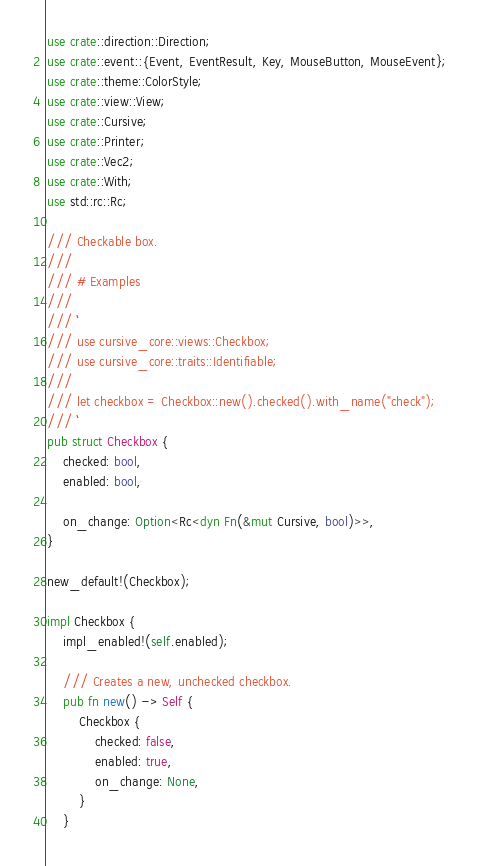Convert code to text. <code><loc_0><loc_0><loc_500><loc_500><_Rust_>use crate::direction::Direction;
use crate::event::{Event, EventResult, Key, MouseButton, MouseEvent};
use crate::theme::ColorStyle;
use crate::view::View;
use crate::Cursive;
use crate::Printer;
use crate::Vec2;
use crate::With;
use std::rc::Rc;

/// Checkable box.
///
/// # Examples
///
/// ```
/// use cursive_core::views::Checkbox;
/// use cursive_core::traits::Identifiable;
///
/// let checkbox = Checkbox::new().checked().with_name("check");
/// ```
pub struct Checkbox {
    checked: bool,
    enabled: bool,

    on_change: Option<Rc<dyn Fn(&mut Cursive, bool)>>,
}

new_default!(Checkbox);

impl Checkbox {
    impl_enabled!(self.enabled);

    /// Creates a new, unchecked checkbox.
    pub fn new() -> Self {
        Checkbox {
            checked: false,
            enabled: true,
            on_change: None,
        }
    }
</code> 